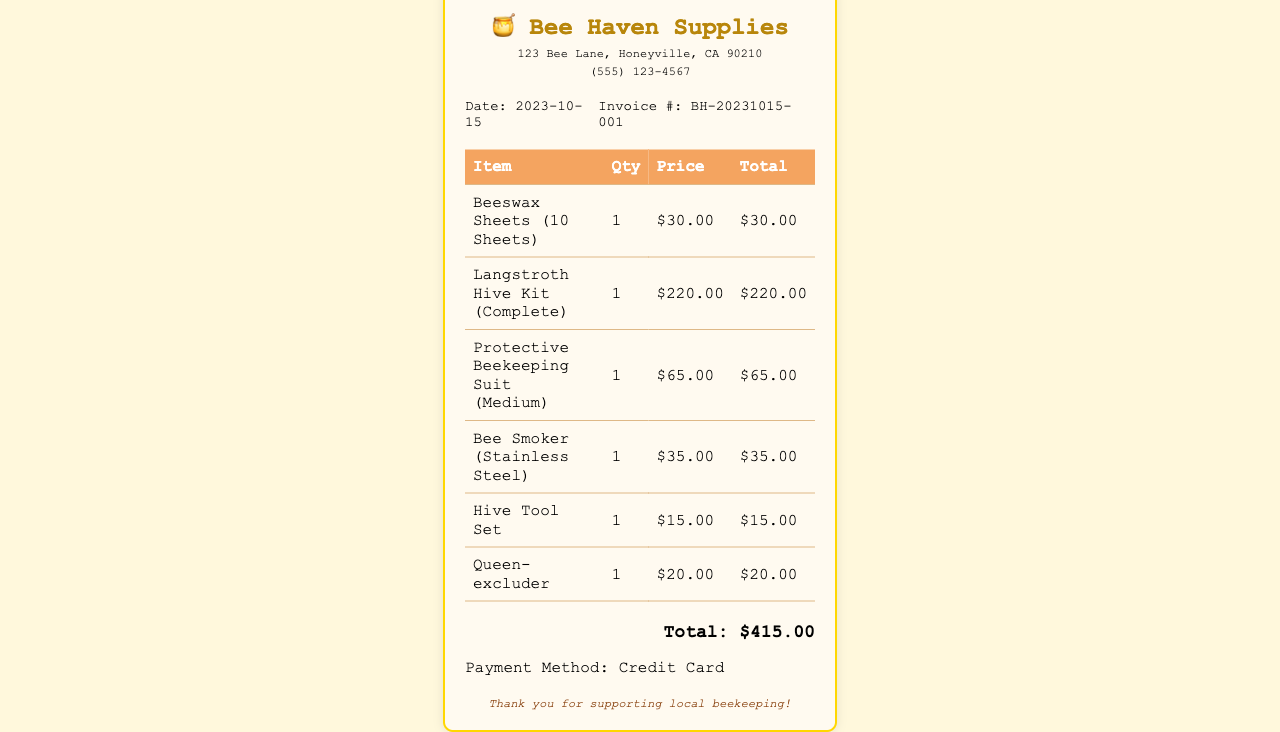What is the date of the purchase? The date of the purchase is mentioned in the invoice details section of the receipt.
Answer: 2023-10-15 What is the total cost of the beeswax sheets? The cost of beeswax sheets is listed as $30.00 in the itemized table of the receipt.
Answer: $30.00 How many items were purchased in total? The total number of items is the sum of all distinct items listed in the receipt, which equals six.
Answer: 6 What is the price of the protective beekeeping suit? The price of the protective beekeeping suit can be found in the item table, which states it costs $65.00.
Answer: $65.00 What payment method was used for the purchase? The payment method is clearly stated at the bottom of the receipt indicating it was paid with a credit card.
Answer: Credit Card What is the total amount spent on hive components? The total amount for hive components includes the Langstroth Hive Kit and the Queen-excluder, adding up to $240.00.
Answer: $240.00 How many queens can the queen-excluder manage? There is no specific mention of how many queens the queen-excluder can manage in the document.
Answer: Not specified What item in the purchase could help in maintaining hive temperature? The bee smoker would help in maintaining hive temperature by calming the bees.
Answer: Bee Smoker 